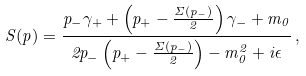Convert formula to latex. <formula><loc_0><loc_0><loc_500><loc_500>S ( p ) = \frac { p _ { - } \gamma _ { + } + \left ( p _ { + } - \frac { \Sigma ( p _ { - } ) } { 2 } \right ) \gamma _ { - } + m _ { 0 } } { 2 p _ { - } \left ( p _ { + } - \frac { \Sigma ( p _ { - } ) } { 2 } \right ) - m _ { 0 } ^ { 2 } + i \epsilon } \, ,</formula> 